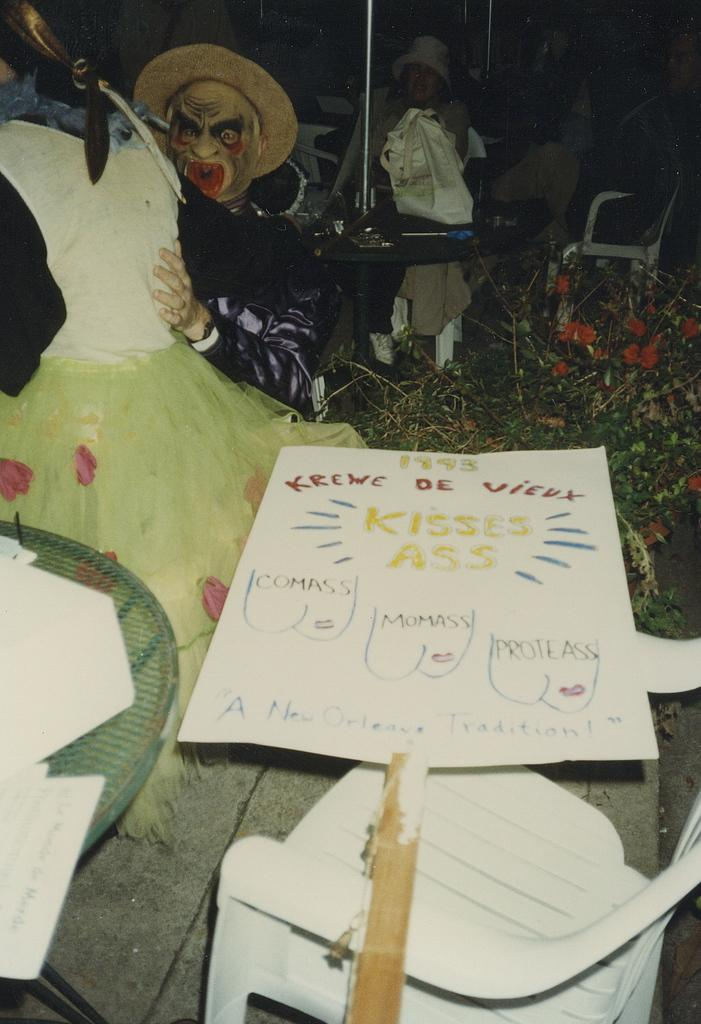<image>
Share a concise interpretation of the image provided. A handwritten fan has pictures and says A New Orleans Tradition. 